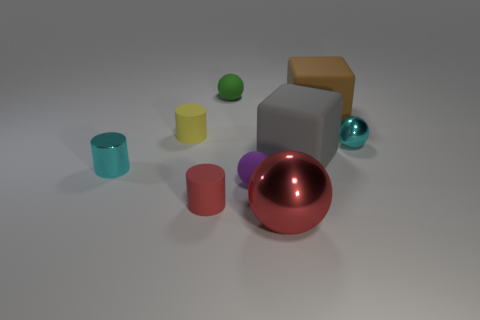What is the color of the cylinder that is made of the same material as the large ball? The color of the cylinder, which shares the same smooth and shiny material as the large ball, is a soft cyan, reflecting a light, tranquil tone that clearly stands out against the neutral background. 